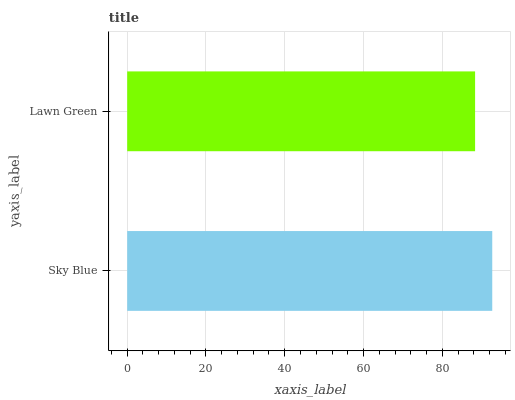Is Lawn Green the minimum?
Answer yes or no. Yes. Is Sky Blue the maximum?
Answer yes or no. Yes. Is Lawn Green the maximum?
Answer yes or no. No. Is Sky Blue greater than Lawn Green?
Answer yes or no. Yes. Is Lawn Green less than Sky Blue?
Answer yes or no. Yes. Is Lawn Green greater than Sky Blue?
Answer yes or no. No. Is Sky Blue less than Lawn Green?
Answer yes or no. No. Is Sky Blue the high median?
Answer yes or no. Yes. Is Lawn Green the low median?
Answer yes or no. Yes. Is Lawn Green the high median?
Answer yes or no. No. Is Sky Blue the low median?
Answer yes or no. No. 